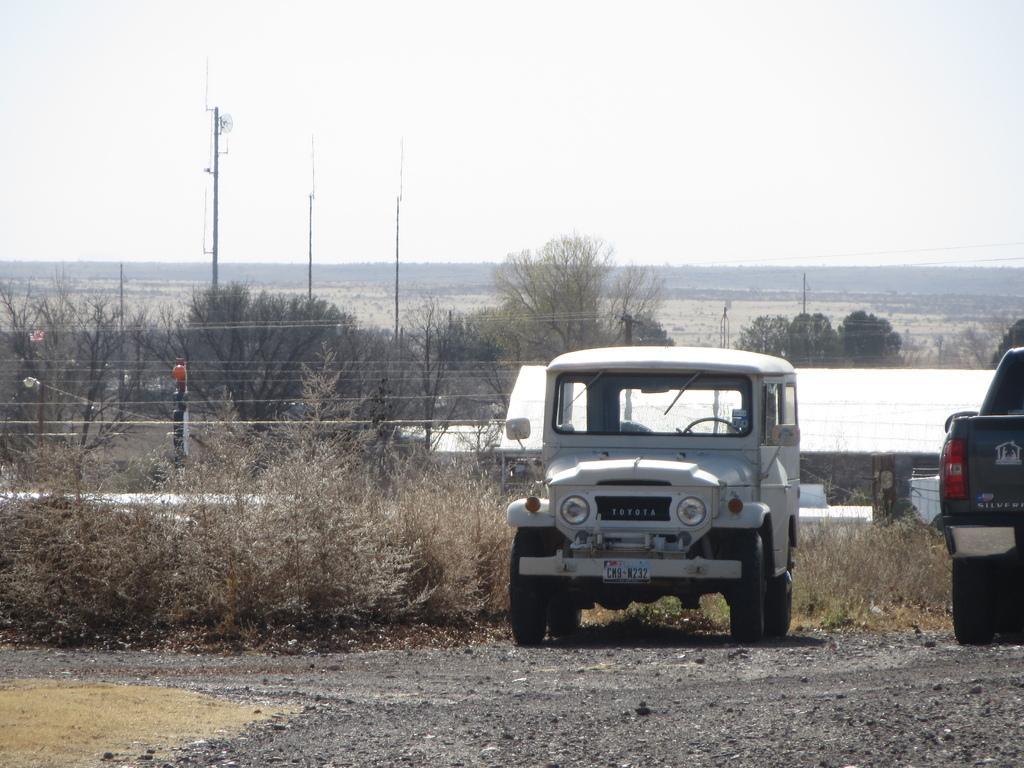Can you describe this image briefly? In this image I can see in the middle there is the jeep in white color, on the right side there is another vehicle, in the middle there are trees. At the top it is the sky. 